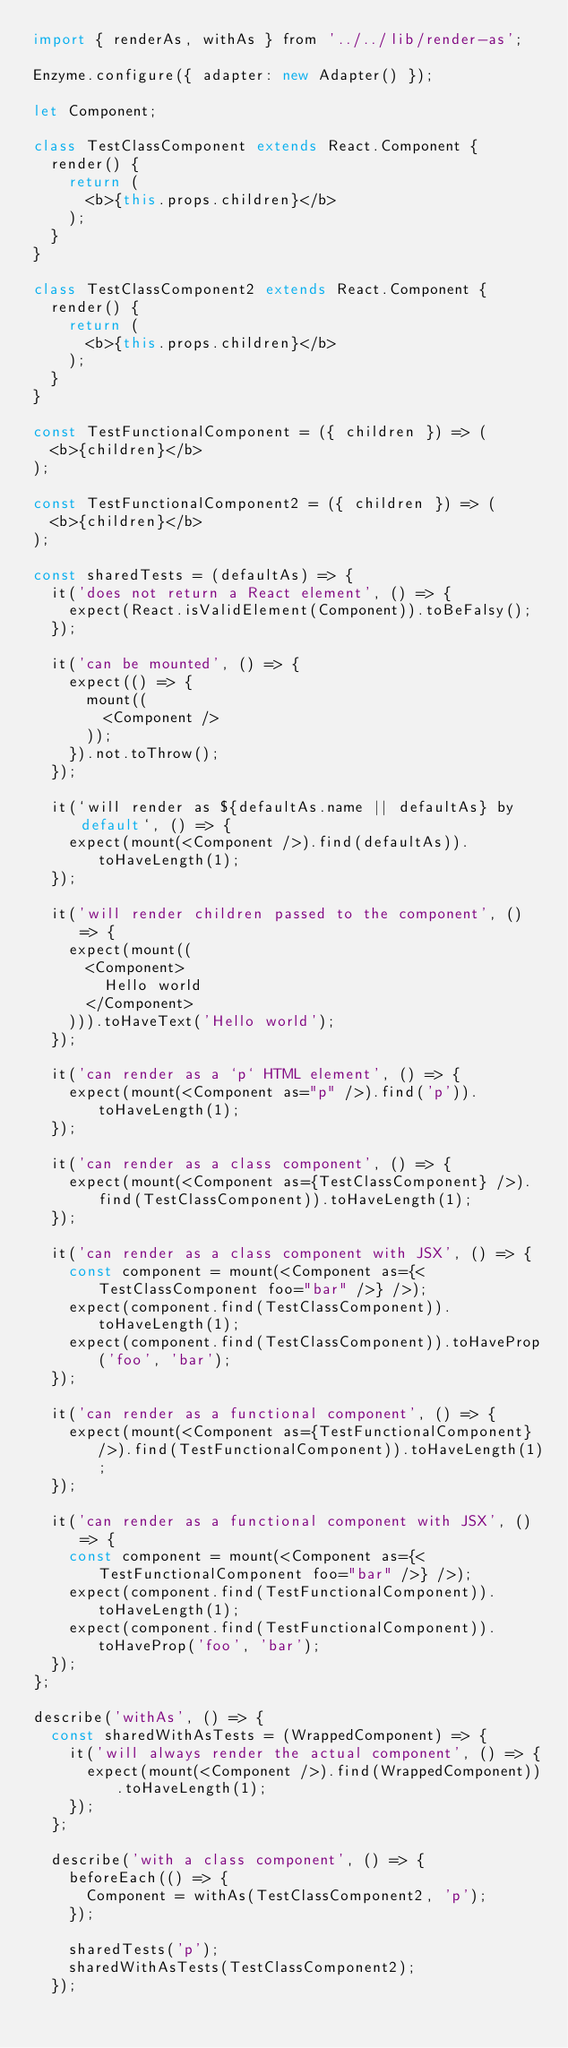Convert code to text. <code><loc_0><loc_0><loc_500><loc_500><_JavaScript_>import { renderAs, withAs } from '../../lib/render-as';

Enzyme.configure({ adapter: new Adapter() });

let Component;

class TestClassComponent extends React.Component {
  render() {
    return (
      <b>{this.props.children}</b>
    );
  }
}

class TestClassComponent2 extends React.Component {
  render() {
    return (
      <b>{this.props.children}</b>
    );
  }
}

const TestFunctionalComponent = ({ children }) => (
  <b>{children}</b>
);

const TestFunctionalComponent2 = ({ children }) => (
  <b>{children}</b>
);

const sharedTests = (defaultAs) => {
  it('does not return a React element', () => {
    expect(React.isValidElement(Component)).toBeFalsy();
  });

  it('can be mounted', () => {
    expect(() => {
      mount((
        <Component />
      ));
    }).not.toThrow();
  });

  it(`will render as ${defaultAs.name || defaultAs} by default`, () => {
    expect(mount(<Component />).find(defaultAs)).toHaveLength(1);
  });

  it('will render children passed to the component', () => {
    expect(mount((
      <Component>
        Hello world
      </Component>
    ))).toHaveText('Hello world');
  });

  it('can render as a `p` HTML element', () => {
    expect(mount(<Component as="p" />).find('p')).toHaveLength(1);
  });

  it('can render as a class component', () => {
    expect(mount(<Component as={TestClassComponent} />).find(TestClassComponent)).toHaveLength(1);
  });

  it('can render as a class component with JSX', () => {
    const component = mount(<Component as={<TestClassComponent foo="bar" />} />);
    expect(component.find(TestClassComponent)).toHaveLength(1);
    expect(component.find(TestClassComponent)).toHaveProp('foo', 'bar');
  });

  it('can render as a functional component', () => {
    expect(mount(<Component as={TestFunctionalComponent} />).find(TestFunctionalComponent)).toHaveLength(1);
  });

  it('can render as a functional component with JSX', () => {
    const component = mount(<Component as={<TestFunctionalComponent foo="bar" />} />);
    expect(component.find(TestFunctionalComponent)).toHaveLength(1);
    expect(component.find(TestFunctionalComponent)).toHaveProp('foo', 'bar');
  });
};

describe('withAs', () => {
  const sharedWithAsTests = (WrappedComponent) => {
    it('will always render the actual component', () => {
      expect(mount(<Component />).find(WrappedComponent)).toHaveLength(1);
    });
  };

  describe('with a class component', () => {
    beforeEach(() => {
      Component = withAs(TestClassComponent2, 'p');
    });

    sharedTests('p');
    sharedWithAsTests(TestClassComponent2);
  });
</code> 